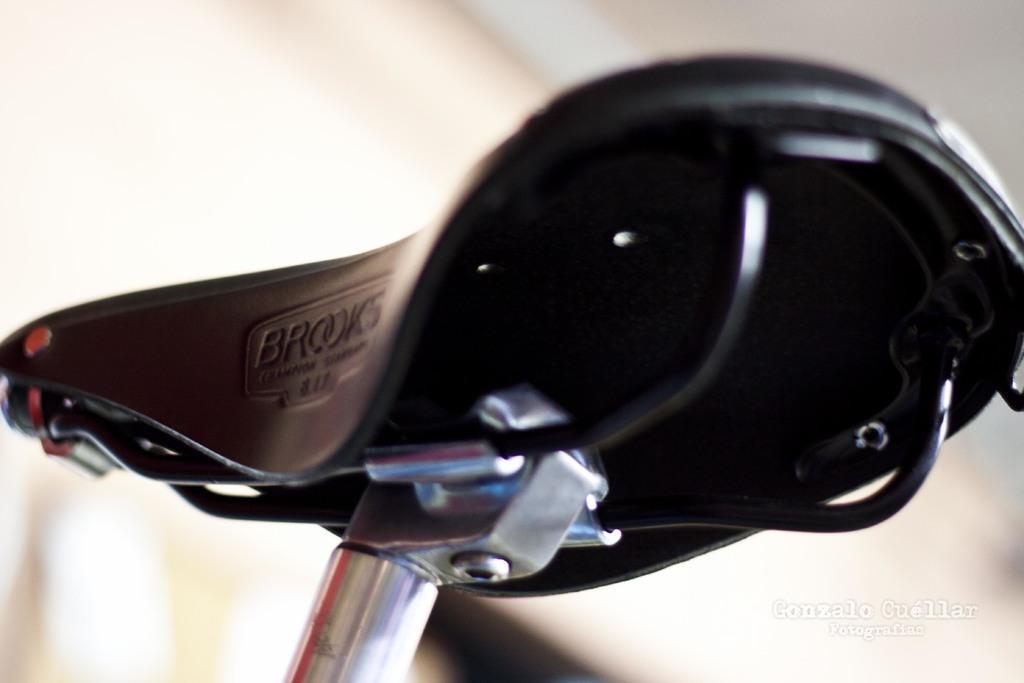Describe this image in one or two sentences. In the center of the image there is a cycle seat. In the background there is a wall. 